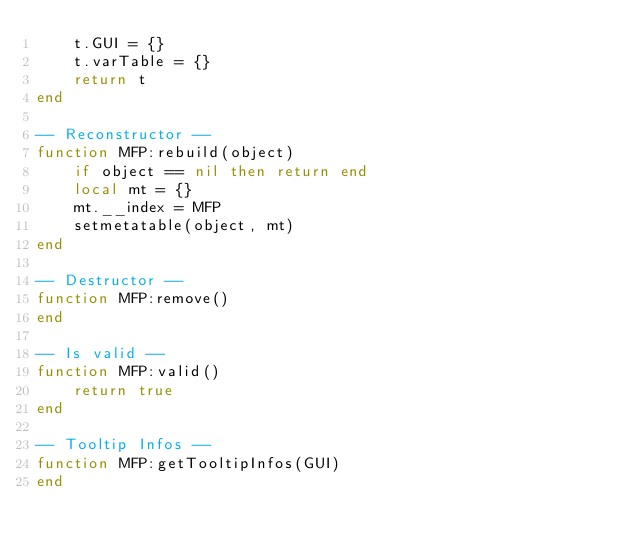Convert code to text. <code><loc_0><loc_0><loc_500><loc_500><_Lua_>	t.GUI = {}
    t.varTable = {}
	return t
end

-- Reconstructor --
function MFP:rebuild(object)
	if object == nil then return end
	local mt = {}
	mt.__index = MFP
	setmetatable(object, mt)
end

-- Destructor --
function MFP:remove()
end

-- Is valid --
function MFP:valid()
	return true
end

-- Tooltip Infos --
function MFP:getTooltipInfos(GUI)
end</code> 